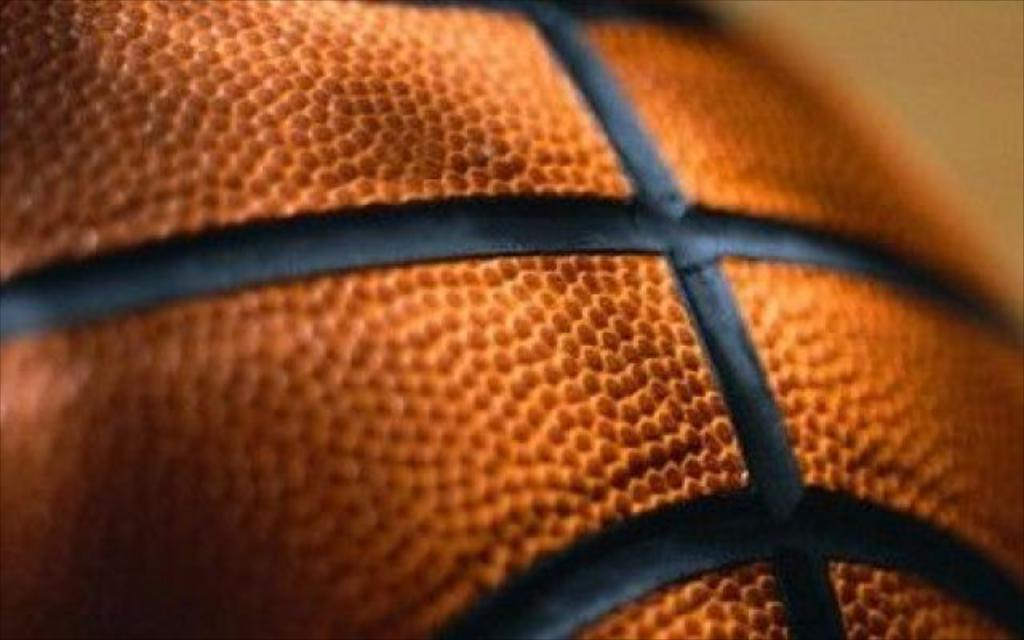What is the main object in the image? The image contains a basketball. Can you describe the background of the image? The background of the image is blurry. What level of education is being taught in the image? There is no indication of any educational setting or level in the image; it only contains a basketball and a blurry background. 